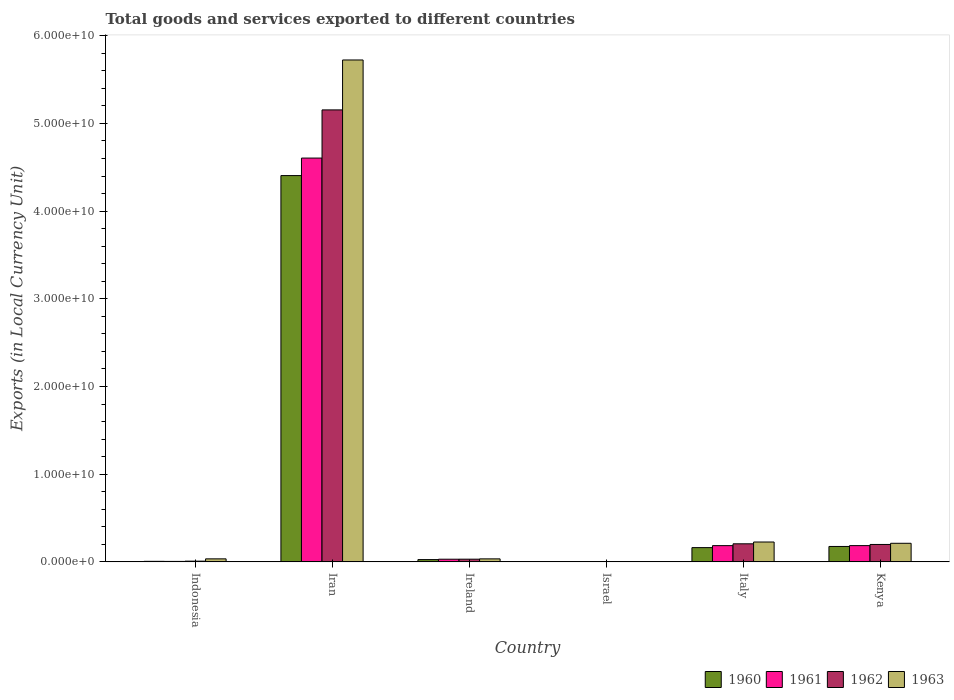Are the number of bars per tick equal to the number of legend labels?
Your answer should be compact. Yes. Are the number of bars on each tick of the X-axis equal?
Ensure brevity in your answer.  Yes. How many bars are there on the 6th tick from the right?
Offer a very short reply. 4. What is the label of the 2nd group of bars from the left?
Your response must be concise. Iran. What is the Amount of goods and services exports in 1960 in Kenya?
Ensure brevity in your answer.  1.76e+09. Across all countries, what is the maximum Amount of goods and services exports in 1961?
Offer a very short reply. 4.60e+1. Across all countries, what is the minimum Amount of goods and services exports in 1960?
Ensure brevity in your answer.  6.19e+04. In which country was the Amount of goods and services exports in 1963 maximum?
Provide a succinct answer. Iran. In which country was the Amount of goods and services exports in 1963 minimum?
Your response must be concise. Israel. What is the total Amount of goods and services exports in 1960 in the graph?
Offer a very short reply. 4.78e+1. What is the difference between the Amount of goods and services exports in 1962 in Israel and that in Kenya?
Provide a succinct answer. -1.99e+09. What is the difference between the Amount of goods and services exports in 1960 in Kenya and the Amount of goods and services exports in 1961 in Indonesia?
Provide a short and direct response. 1.70e+09. What is the average Amount of goods and services exports in 1961 per country?
Provide a short and direct response. 8.35e+09. What is the difference between the Amount of goods and services exports of/in 1962 and Amount of goods and services exports of/in 1961 in Ireland?
Provide a short and direct response. 2.58e+06. What is the ratio of the Amount of goods and services exports in 1963 in Iran to that in Kenya?
Keep it short and to the point. 27. Is the Amount of goods and services exports in 1961 in Indonesia less than that in Iran?
Your answer should be compact. Yes. Is the difference between the Amount of goods and services exports in 1962 in Indonesia and Iran greater than the difference between the Amount of goods and services exports in 1961 in Indonesia and Iran?
Offer a terse response. No. What is the difference between the highest and the second highest Amount of goods and services exports in 1963?
Provide a succinct answer. -5.50e+1. What is the difference between the highest and the lowest Amount of goods and services exports in 1962?
Your response must be concise. 5.15e+1. Is the sum of the Amount of goods and services exports in 1960 in Indonesia and Kenya greater than the maximum Amount of goods and services exports in 1963 across all countries?
Ensure brevity in your answer.  No. Is it the case that in every country, the sum of the Amount of goods and services exports in 1962 and Amount of goods and services exports in 1961 is greater than the sum of Amount of goods and services exports in 1963 and Amount of goods and services exports in 1960?
Make the answer very short. No. What does the 1st bar from the right in Ireland represents?
Make the answer very short. 1963. Are all the bars in the graph horizontal?
Make the answer very short. No. What is the difference between two consecutive major ticks on the Y-axis?
Provide a short and direct response. 1.00e+1. Are the values on the major ticks of Y-axis written in scientific E-notation?
Give a very brief answer. Yes. Does the graph contain grids?
Provide a short and direct response. No. How many legend labels are there?
Make the answer very short. 4. How are the legend labels stacked?
Give a very brief answer. Horizontal. What is the title of the graph?
Keep it short and to the point. Total goods and services exported to different countries. What is the label or title of the X-axis?
Provide a succinct answer. Country. What is the label or title of the Y-axis?
Keep it short and to the point. Exports (in Local Currency Unit). What is the Exports (in Local Currency Unit) in 1960 in Indonesia?
Provide a short and direct response. 6.20e+07. What is the Exports (in Local Currency Unit) of 1961 in Indonesia?
Ensure brevity in your answer.  5.31e+07. What is the Exports (in Local Currency Unit) of 1962 in Indonesia?
Provide a succinct answer. 8.19e+07. What is the Exports (in Local Currency Unit) in 1963 in Indonesia?
Your answer should be very brief. 3.44e+08. What is the Exports (in Local Currency Unit) in 1960 in Iran?
Give a very brief answer. 4.41e+1. What is the Exports (in Local Currency Unit) in 1961 in Iran?
Offer a very short reply. 4.60e+1. What is the Exports (in Local Currency Unit) of 1962 in Iran?
Offer a terse response. 5.15e+1. What is the Exports (in Local Currency Unit) of 1963 in Iran?
Your response must be concise. 5.72e+1. What is the Exports (in Local Currency Unit) in 1960 in Ireland?
Keep it short and to the point. 2.60e+08. What is the Exports (in Local Currency Unit) in 1961 in Ireland?
Give a very brief answer. 3.04e+08. What is the Exports (in Local Currency Unit) in 1962 in Ireland?
Your response must be concise. 3.07e+08. What is the Exports (in Local Currency Unit) in 1963 in Ireland?
Offer a very short reply. 3.43e+08. What is the Exports (in Local Currency Unit) in 1960 in Israel?
Ensure brevity in your answer.  6.19e+04. What is the Exports (in Local Currency Unit) of 1961 in Israel?
Offer a very short reply. 7.24e+04. What is the Exports (in Local Currency Unit) of 1962 in Israel?
Offer a terse response. 1.34e+05. What is the Exports (in Local Currency Unit) of 1963 in Israel?
Your answer should be very brief. 1.67e+05. What is the Exports (in Local Currency Unit) in 1960 in Italy?
Your answer should be very brief. 1.63e+09. What is the Exports (in Local Currency Unit) of 1961 in Italy?
Offer a terse response. 1.85e+09. What is the Exports (in Local Currency Unit) in 1962 in Italy?
Give a very brief answer. 2.06e+09. What is the Exports (in Local Currency Unit) in 1963 in Italy?
Your response must be concise. 2.27e+09. What is the Exports (in Local Currency Unit) in 1960 in Kenya?
Offer a very short reply. 1.76e+09. What is the Exports (in Local Currency Unit) of 1961 in Kenya?
Ensure brevity in your answer.  1.85e+09. What is the Exports (in Local Currency Unit) of 1962 in Kenya?
Offer a terse response. 1.99e+09. What is the Exports (in Local Currency Unit) in 1963 in Kenya?
Provide a succinct answer. 2.12e+09. Across all countries, what is the maximum Exports (in Local Currency Unit) of 1960?
Offer a terse response. 4.41e+1. Across all countries, what is the maximum Exports (in Local Currency Unit) of 1961?
Ensure brevity in your answer.  4.60e+1. Across all countries, what is the maximum Exports (in Local Currency Unit) of 1962?
Your response must be concise. 5.15e+1. Across all countries, what is the maximum Exports (in Local Currency Unit) in 1963?
Keep it short and to the point. 5.72e+1. Across all countries, what is the minimum Exports (in Local Currency Unit) in 1960?
Make the answer very short. 6.19e+04. Across all countries, what is the minimum Exports (in Local Currency Unit) of 1961?
Provide a succinct answer. 7.24e+04. Across all countries, what is the minimum Exports (in Local Currency Unit) of 1962?
Offer a very short reply. 1.34e+05. Across all countries, what is the minimum Exports (in Local Currency Unit) of 1963?
Provide a succinct answer. 1.67e+05. What is the total Exports (in Local Currency Unit) in 1960 in the graph?
Offer a terse response. 4.78e+1. What is the total Exports (in Local Currency Unit) of 1961 in the graph?
Give a very brief answer. 5.01e+1. What is the total Exports (in Local Currency Unit) of 1962 in the graph?
Keep it short and to the point. 5.60e+1. What is the total Exports (in Local Currency Unit) in 1963 in the graph?
Give a very brief answer. 6.23e+1. What is the difference between the Exports (in Local Currency Unit) in 1960 in Indonesia and that in Iran?
Offer a very short reply. -4.40e+1. What is the difference between the Exports (in Local Currency Unit) in 1961 in Indonesia and that in Iran?
Keep it short and to the point. -4.60e+1. What is the difference between the Exports (in Local Currency Unit) in 1962 in Indonesia and that in Iran?
Make the answer very short. -5.15e+1. What is the difference between the Exports (in Local Currency Unit) of 1963 in Indonesia and that in Iran?
Make the answer very short. -5.69e+1. What is the difference between the Exports (in Local Currency Unit) in 1960 in Indonesia and that in Ireland?
Ensure brevity in your answer.  -1.98e+08. What is the difference between the Exports (in Local Currency Unit) of 1961 in Indonesia and that in Ireland?
Offer a terse response. -2.51e+08. What is the difference between the Exports (in Local Currency Unit) of 1962 in Indonesia and that in Ireland?
Provide a short and direct response. -2.25e+08. What is the difference between the Exports (in Local Currency Unit) of 1963 in Indonesia and that in Ireland?
Your answer should be compact. 1.22e+06. What is the difference between the Exports (in Local Currency Unit) of 1960 in Indonesia and that in Israel?
Your answer should be compact. 6.19e+07. What is the difference between the Exports (in Local Currency Unit) of 1961 in Indonesia and that in Israel?
Offer a terse response. 5.31e+07. What is the difference between the Exports (in Local Currency Unit) in 1962 in Indonesia and that in Israel?
Offer a very short reply. 8.18e+07. What is the difference between the Exports (in Local Currency Unit) of 1963 in Indonesia and that in Israel?
Your answer should be compact. 3.44e+08. What is the difference between the Exports (in Local Currency Unit) of 1960 in Indonesia and that in Italy?
Make the answer very short. -1.56e+09. What is the difference between the Exports (in Local Currency Unit) of 1961 in Indonesia and that in Italy?
Your answer should be compact. -1.80e+09. What is the difference between the Exports (in Local Currency Unit) in 1962 in Indonesia and that in Italy?
Your response must be concise. -1.98e+09. What is the difference between the Exports (in Local Currency Unit) of 1963 in Indonesia and that in Italy?
Make the answer very short. -1.92e+09. What is the difference between the Exports (in Local Currency Unit) in 1960 in Indonesia and that in Kenya?
Your response must be concise. -1.70e+09. What is the difference between the Exports (in Local Currency Unit) of 1961 in Indonesia and that in Kenya?
Give a very brief answer. -1.80e+09. What is the difference between the Exports (in Local Currency Unit) of 1962 in Indonesia and that in Kenya?
Your answer should be very brief. -1.90e+09. What is the difference between the Exports (in Local Currency Unit) in 1963 in Indonesia and that in Kenya?
Provide a short and direct response. -1.78e+09. What is the difference between the Exports (in Local Currency Unit) of 1960 in Iran and that in Ireland?
Your answer should be compact. 4.38e+1. What is the difference between the Exports (in Local Currency Unit) in 1961 in Iran and that in Ireland?
Give a very brief answer. 4.57e+1. What is the difference between the Exports (in Local Currency Unit) in 1962 in Iran and that in Ireland?
Provide a succinct answer. 5.12e+1. What is the difference between the Exports (in Local Currency Unit) of 1963 in Iran and that in Ireland?
Ensure brevity in your answer.  5.69e+1. What is the difference between the Exports (in Local Currency Unit) of 1960 in Iran and that in Israel?
Ensure brevity in your answer.  4.41e+1. What is the difference between the Exports (in Local Currency Unit) of 1961 in Iran and that in Israel?
Ensure brevity in your answer.  4.60e+1. What is the difference between the Exports (in Local Currency Unit) in 1962 in Iran and that in Israel?
Provide a short and direct response. 5.15e+1. What is the difference between the Exports (in Local Currency Unit) of 1963 in Iran and that in Israel?
Your answer should be very brief. 5.72e+1. What is the difference between the Exports (in Local Currency Unit) in 1960 in Iran and that in Italy?
Make the answer very short. 4.24e+1. What is the difference between the Exports (in Local Currency Unit) of 1961 in Iran and that in Italy?
Provide a succinct answer. 4.42e+1. What is the difference between the Exports (in Local Currency Unit) in 1962 in Iran and that in Italy?
Offer a terse response. 4.95e+1. What is the difference between the Exports (in Local Currency Unit) in 1963 in Iran and that in Italy?
Your answer should be very brief. 5.50e+1. What is the difference between the Exports (in Local Currency Unit) in 1960 in Iran and that in Kenya?
Give a very brief answer. 4.23e+1. What is the difference between the Exports (in Local Currency Unit) of 1961 in Iran and that in Kenya?
Offer a very short reply. 4.42e+1. What is the difference between the Exports (in Local Currency Unit) of 1962 in Iran and that in Kenya?
Provide a succinct answer. 4.96e+1. What is the difference between the Exports (in Local Currency Unit) of 1963 in Iran and that in Kenya?
Keep it short and to the point. 5.51e+1. What is the difference between the Exports (in Local Currency Unit) of 1960 in Ireland and that in Israel?
Provide a short and direct response. 2.60e+08. What is the difference between the Exports (in Local Currency Unit) of 1961 in Ireland and that in Israel?
Keep it short and to the point. 3.04e+08. What is the difference between the Exports (in Local Currency Unit) of 1962 in Ireland and that in Israel?
Ensure brevity in your answer.  3.06e+08. What is the difference between the Exports (in Local Currency Unit) in 1963 in Ireland and that in Israel?
Offer a very short reply. 3.43e+08. What is the difference between the Exports (in Local Currency Unit) of 1960 in Ireland and that in Italy?
Your response must be concise. -1.37e+09. What is the difference between the Exports (in Local Currency Unit) of 1961 in Ireland and that in Italy?
Give a very brief answer. -1.55e+09. What is the difference between the Exports (in Local Currency Unit) in 1962 in Ireland and that in Italy?
Offer a very short reply. -1.75e+09. What is the difference between the Exports (in Local Currency Unit) in 1963 in Ireland and that in Italy?
Make the answer very short. -1.92e+09. What is the difference between the Exports (in Local Currency Unit) of 1960 in Ireland and that in Kenya?
Provide a succinct answer. -1.50e+09. What is the difference between the Exports (in Local Currency Unit) in 1961 in Ireland and that in Kenya?
Provide a succinct answer. -1.55e+09. What is the difference between the Exports (in Local Currency Unit) in 1962 in Ireland and that in Kenya?
Offer a very short reply. -1.68e+09. What is the difference between the Exports (in Local Currency Unit) of 1963 in Ireland and that in Kenya?
Offer a very short reply. -1.78e+09. What is the difference between the Exports (in Local Currency Unit) in 1960 in Israel and that in Italy?
Your answer should be compact. -1.63e+09. What is the difference between the Exports (in Local Currency Unit) in 1961 in Israel and that in Italy?
Offer a very short reply. -1.85e+09. What is the difference between the Exports (in Local Currency Unit) of 1962 in Israel and that in Italy?
Provide a short and direct response. -2.06e+09. What is the difference between the Exports (in Local Currency Unit) of 1963 in Israel and that in Italy?
Ensure brevity in your answer.  -2.27e+09. What is the difference between the Exports (in Local Currency Unit) in 1960 in Israel and that in Kenya?
Your response must be concise. -1.76e+09. What is the difference between the Exports (in Local Currency Unit) in 1961 in Israel and that in Kenya?
Provide a succinct answer. -1.85e+09. What is the difference between the Exports (in Local Currency Unit) in 1962 in Israel and that in Kenya?
Your answer should be compact. -1.99e+09. What is the difference between the Exports (in Local Currency Unit) of 1963 in Israel and that in Kenya?
Offer a very short reply. -2.12e+09. What is the difference between the Exports (in Local Currency Unit) in 1960 in Italy and that in Kenya?
Make the answer very short. -1.31e+08. What is the difference between the Exports (in Local Currency Unit) of 1961 in Italy and that in Kenya?
Offer a very short reply. -1.45e+06. What is the difference between the Exports (in Local Currency Unit) of 1962 in Italy and that in Kenya?
Ensure brevity in your answer.  7.40e+07. What is the difference between the Exports (in Local Currency Unit) of 1963 in Italy and that in Kenya?
Your answer should be compact. 1.46e+08. What is the difference between the Exports (in Local Currency Unit) of 1960 in Indonesia and the Exports (in Local Currency Unit) of 1961 in Iran?
Your answer should be very brief. -4.60e+1. What is the difference between the Exports (in Local Currency Unit) in 1960 in Indonesia and the Exports (in Local Currency Unit) in 1962 in Iran?
Give a very brief answer. -5.15e+1. What is the difference between the Exports (in Local Currency Unit) in 1960 in Indonesia and the Exports (in Local Currency Unit) in 1963 in Iran?
Your response must be concise. -5.72e+1. What is the difference between the Exports (in Local Currency Unit) of 1961 in Indonesia and the Exports (in Local Currency Unit) of 1962 in Iran?
Give a very brief answer. -5.15e+1. What is the difference between the Exports (in Local Currency Unit) of 1961 in Indonesia and the Exports (in Local Currency Unit) of 1963 in Iran?
Your response must be concise. -5.72e+1. What is the difference between the Exports (in Local Currency Unit) in 1962 in Indonesia and the Exports (in Local Currency Unit) in 1963 in Iran?
Give a very brief answer. -5.72e+1. What is the difference between the Exports (in Local Currency Unit) of 1960 in Indonesia and the Exports (in Local Currency Unit) of 1961 in Ireland?
Offer a very short reply. -2.42e+08. What is the difference between the Exports (in Local Currency Unit) in 1960 in Indonesia and the Exports (in Local Currency Unit) in 1962 in Ireland?
Your response must be concise. -2.45e+08. What is the difference between the Exports (in Local Currency Unit) in 1960 in Indonesia and the Exports (in Local Currency Unit) in 1963 in Ireland?
Give a very brief answer. -2.81e+08. What is the difference between the Exports (in Local Currency Unit) in 1961 in Indonesia and the Exports (in Local Currency Unit) in 1962 in Ireland?
Make the answer very short. -2.53e+08. What is the difference between the Exports (in Local Currency Unit) in 1961 in Indonesia and the Exports (in Local Currency Unit) in 1963 in Ireland?
Offer a very short reply. -2.90e+08. What is the difference between the Exports (in Local Currency Unit) of 1962 in Indonesia and the Exports (in Local Currency Unit) of 1963 in Ireland?
Provide a succinct answer. -2.61e+08. What is the difference between the Exports (in Local Currency Unit) of 1960 in Indonesia and the Exports (in Local Currency Unit) of 1961 in Israel?
Provide a short and direct response. 6.19e+07. What is the difference between the Exports (in Local Currency Unit) in 1960 in Indonesia and the Exports (in Local Currency Unit) in 1962 in Israel?
Your answer should be very brief. 6.18e+07. What is the difference between the Exports (in Local Currency Unit) of 1960 in Indonesia and the Exports (in Local Currency Unit) of 1963 in Israel?
Make the answer very short. 6.18e+07. What is the difference between the Exports (in Local Currency Unit) of 1961 in Indonesia and the Exports (in Local Currency Unit) of 1962 in Israel?
Your response must be concise. 5.30e+07. What is the difference between the Exports (in Local Currency Unit) of 1961 in Indonesia and the Exports (in Local Currency Unit) of 1963 in Israel?
Ensure brevity in your answer.  5.30e+07. What is the difference between the Exports (in Local Currency Unit) in 1962 in Indonesia and the Exports (in Local Currency Unit) in 1963 in Israel?
Your answer should be compact. 8.17e+07. What is the difference between the Exports (in Local Currency Unit) in 1960 in Indonesia and the Exports (in Local Currency Unit) in 1961 in Italy?
Your answer should be very brief. -1.79e+09. What is the difference between the Exports (in Local Currency Unit) in 1960 in Indonesia and the Exports (in Local Currency Unit) in 1962 in Italy?
Provide a short and direct response. -2.00e+09. What is the difference between the Exports (in Local Currency Unit) in 1960 in Indonesia and the Exports (in Local Currency Unit) in 1963 in Italy?
Your answer should be compact. -2.20e+09. What is the difference between the Exports (in Local Currency Unit) of 1961 in Indonesia and the Exports (in Local Currency Unit) of 1962 in Italy?
Make the answer very short. -2.01e+09. What is the difference between the Exports (in Local Currency Unit) of 1961 in Indonesia and the Exports (in Local Currency Unit) of 1963 in Italy?
Your answer should be compact. -2.21e+09. What is the difference between the Exports (in Local Currency Unit) in 1962 in Indonesia and the Exports (in Local Currency Unit) in 1963 in Italy?
Provide a succinct answer. -2.18e+09. What is the difference between the Exports (in Local Currency Unit) of 1960 in Indonesia and the Exports (in Local Currency Unit) of 1961 in Kenya?
Your answer should be very brief. -1.79e+09. What is the difference between the Exports (in Local Currency Unit) of 1960 in Indonesia and the Exports (in Local Currency Unit) of 1962 in Kenya?
Provide a short and direct response. -1.92e+09. What is the difference between the Exports (in Local Currency Unit) of 1960 in Indonesia and the Exports (in Local Currency Unit) of 1963 in Kenya?
Give a very brief answer. -2.06e+09. What is the difference between the Exports (in Local Currency Unit) of 1961 in Indonesia and the Exports (in Local Currency Unit) of 1962 in Kenya?
Provide a succinct answer. -1.93e+09. What is the difference between the Exports (in Local Currency Unit) in 1961 in Indonesia and the Exports (in Local Currency Unit) in 1963 in Kenya?
Offer a terse response. -2.07e+09. What is the difference between the Exports (in Local Currency Unit) in 1962 in Indonesia and the Exports (in Local Currency Unit) in 1963 in Kenya?
Keep it short and to the point. -2.04e+09. What is the difference between the Exports (in Local Currency Unit) of 1960 in Iran and the Exports (in Local Currency Unit) of 1961 in Ireland?
Ensure brevity in your answer.  4.37e+1. What is the difference between the Exports (in Local Currency Unit) in 1960 in Iran and the Exports (in Local Currency Unit) in 1962 in Ireland?
Give a very brief answer. 4.37e+1. What is the difference between the Exports (in Local Currency Unit) in 1960 in Iran and the Exports (in Local Currency Unit) in 1963 in Ireland?
Your response must be concise. 4.37e+1. What is the difference between the Exports (in Local Currency Unit) in 1961 in Iran and the Exports (in Local Currency Unit) in 1962 in Ireland?
Offer a very short reply. 4.57e+1. What is the difference between the Exports (in Local Currency Unit) in 1961 in Iran and the Exports (in Local Currency Unit) in 1963 in Ireland?
Provide a succinct answer. 4.57e+1. What is the difference between the Exports (in Local Currency Unit) in 1962 in Iran and the Exports (in Local Currency Unit) in 1963 in Ireland?
Give a very brief answer. 5.12e+1. What is the difference between the Exports (in Local Currency Unit) of 1960 in Iran and the Exports (in Local Currency Unit) of 1961 in Israel?
Keep it short and to the point. 4.41e+1. What is the difference between the Exports (in Local Currency Unit) of 1960 in Iran and the Exports (in Local Currency Unit) of 1962 in Israel?
Provide a short and direct response. 4.41e+1. What is the difference between the Exports (in Local Currency Unit) in 1960 in Iran and the Exports (in Local Currency Unit) in 1963 in Israel?
Offer a terse response. 4.41e+1. What is the difference between the Exports (in Local Currency Unit) in 1961 in Iran and the Exports (in Local Currency Unit) in 1962 in Israel?
Your response must be concise. 4.60e+1. What is the difference between the Exports (in Local Currency Unit) in 1961 in Iran and the Exports (in Local Currency Unit) in 1963 in Israel?
Offer a terse response. 4.60e+1. What is the difference between the Exports (in Local Currency Unit) of 1962 in Iran and the Exports (in Local Currency Unit) of 1963 in Israel?
Offer a very short reply. 5.15e+1. What is the difference between the Exports (in Local Currency Unit) in 1960 in Iran and the Exports (in Local Currency Unit) in 1961 in Italy?
Offer a terse response. 4.22e+1. What is the difference between the Exports (in Local Currency Unit) of 1960 in Iran and the Exports (in Local Currency Unit) of 1962 in Italy?
Your answer should be compact. 4.20e+1. What is the difference between the Exports (in Local Currency Unit) in 1960 in Iran and the Exports (in Local Currency Unit) in 1963 in Italy?
Offer a terse response. 4.18e+1. What is the difference between the Exports (in Local Currency Unit) in 1961 in Iran and the Exports (in Local Currency Unit) in 1962 in Italy?
Keep it short and to the point. 4.40e+1. What is the difference between the Exports (in Local Currency Unit) of 1961 in Iran and the Exports (in Local Currency Unit) of 1963 in Italy?
Keep it short and to the point. 4.38e+1. What is the difference between the Exports (in Local Currency Unit) in 1962 in Iran and the Exports (in Local Currency Unit) in 1963 in Italy?
Provide a succinct answer. 4.93e+1. What is the difference between the Exports (in Local Currency Unit) of 1960 in Iran and the Exports (in Local Currency Unit) of 1961 in Kenya?
Provide a succinct answer. 4.22e+1. What is the difference between the Exports (in Local Currency Unit) of 1960 in Iran and the Exports (in Local Currency Unit) of 1962 in Kenya?
Offer a terse response. 4.21e+1. What is the difference between the Exports (in Local Currency Unit) in 1960 in Iran and the Exports (in Local Currency Unit) in 1963 in Kenya?
Make the answer very short. 4.19e+1. What is the difference between the Exports (in Local Currency Unit) in 1961 in Iran and the Exports (in Local Currency Unit) in 1962 in Kenya?
Ensure brevity in your answer.  4.41e+1. What is the difference between the Exports (in Local Currency Unit) of 1961 in Iran and the Exports (in Local Currency Unit) of 1963 in Kenya?
Offer a terse response. 4.39e+1. What is the difference between the Exports (in Local Currency Unit) of 1962 in Iran and the Exports (in Local Currency Unit) of 1963 in Kenya?
Offer a terse response. 4.94e+1. What is the difference between the Exports (in Local Currency Unit) of 1960 in Ireland and the Exports (in Local Currency Unit) of 1961 in Israel?
Offer a very short reply. 2.60e+08. What is the difference between the Exports (in Local Currency Unit) of 1960 in Ireland and the Exports (in Local Currency Unit) of 1962 in Israel?
Offer a terse response. 2.60e+08. What is the difference between the Exports (in Local Currency Unit) of 1960 in Ireland and the Exports (in Local Currency Unit) of 1963 in Israel?
Your answer should be compact. 2.60e+08. What is the difference between the Exports (in Local Currency Unit) in 1961 in Ireland and the Exports (in Local Currency Unit) in 1962 in Israel?
Make the answer very short. 3.04e+08. What is the difference between the Exports (in Local Currency Unit) in 1961 in Ireland and the Exports (in Local Currency Unit) in 1963 in Israel?
Your answer should be compact. 3.04e+08. What is the difference between the Exports (in Local Currency Unit) of 1962 in Ireland and the Exports (in Local Currency Unit) of 1963 in Israel?
Keep it short and to the point. 3.06e+08. What is the difference between the Exports (in Local Currency Unit) in 1960 in Ireland and the Exports (in Local Currency Unit) in 1961 in Italy?
Provide a succinct answer. -1.59e+09. What is the difference between the Exports (in Local Currency Unit) of 1960 in Ireland and the Exports (in Local Currency Unit) of 1962 in Italy?
Your response must be concise. -1.80e+09. What is the difference between the Exports (in Local Currency Unit) in 1960 in Ireland and the Exports (in Local Currency Unit) in 1963 in Italy?
Your response must be concise. -2.01e+09. What is the difference between the Exports (in Local Currency Unit) in 1961 in Ireland and the Exports (in Local Currency Unit) in 1962 in Italy?
Offer a terse response. -1.76e+09. What is the difference between the Exports (in Local Currency Unit) of 1961 in Ireland and the Exports (in Local Currency Unit) of 1963 in Italy?
Provide a succinct answer. -1.96e+09. What is the difference between the Exports (in Local Currency Unit) in 1962 in Ireland and the Exports (in Local Currency Unit) in 1963 in Italy?
Give a very brief answer. -1.96e+09. What is the difference between the Exports (in Local Currency Unit) in 1960 in Ireland and the Exports (in Local Currency Unit) in 1961 in Kenya?
Your response must be concise. -1.59e+09. What is the difference between the Exports (in Local Currency Unit) of 1960 in Ireland and the Exports (in Local Currency Unit) of 1962 in Kenya?
Your answer should be very brief. -1.73e+09. What is the difference between the Exports (in Local Currency Unit) of 1960 in Ireland and the Exports (in Local Currency Unit) of 1963 in Kenya?
Your response must be concise. -1.86e+09. What is the difference between the Exports (in Local Currency Unit) of 1961 in Ireland and the Exports (in Local Currency Unit) of 1962 in Kenya?
Provide a succinct answer. -1.68e+09. What is the difference between the Exports (in Local Currency Unit) in 1961 in Ireland and the Exports (in Local Currency Unit) in 1963 in Kenya?
Your answer should be very brief. -1.82e+09. What is the difference between the Exports (in Local Currency Unit) of 1962 in Ireland and the Exports (in Local Currency Unit) of 1963 in Kenya?
Provide a short and direct response. -1.81e+09. What is the difference between the Exports (in Local Currency Unit) of 1960 in Israel and the Exports (in Local Currency Unit) of 1961 in Italy?
Offer a very short reply. -1.85e+09. What is the difference between the Exports (in Local Currency Unit) in 1960 in Israel and the Exports (in Local Currency Unit) in 1962 in Italy?
Offer a terse response. -2.06e+09. What is the difference between the Exports (in Local Currency Unit) of 1960 in Israel and the Exports (in Local Currency Unit) of 1963 in Italy?
Offer a very short reply. -2.27e+09. What is the difference between the Exports (in Local Currency Unit) in 1961 in Israel and the Exports (in Local Currency Unit) in 1962 in Italy?
Your answer should be very brief. -2.06e+09. What is the difference between the Exports (in Local Currency Unit) in 1961 in Israel and the Exports (in Local Currency Unit) in 1963 in Italy?
Provide a short and direct response. -2.27e+09. What is the difference between the Exports (in Local Currency Unit) in 1962 in Israel and the Exports (in Local Currency Unit) in 1963 in Italy?
Give a very brief answer. -2.27e+09. What is the difference between the Exports (in Local Currency Unit) of 1960 in Israel and the Exports (in Local Currency Unit) of 1961 in Kenya?
Keep it short and to the point. -1.85e+09. What is the difference between the Exports (in Local Currency Unit) in 1960 in Israel and the Exports (in Local Currency Unit) in 1962 in Kenya?
Make the answer very short. -1.99e+09. What is the difference between the Exports (in Local Currency Unit) in 1960 in Israel and the Exports (in Local Currency Unit) in 1963 in Kenya?
Your answer should be very brief. -2.12e+09. What is the difference between the Exports (in Local Currency Unit) of 1961 in Israel and the Exports (in Local Currency Unit) of 1962 in Kenya?
Give a very brief answer. -1.99e+09. What is the difference between the Exports (in Local Currency Unit) of 1961 in Israel and the Exports (in Local Currency Unit) of 1963 in Kenya?
Offer a terse response. -2.12e+09. What is the difference between the Exports (in Local Currency Unit) of 1962 in Israel and the Exports (in Local Currency Unit) of 1963 in Kenya?
Provide a short and direct response. -2.12e+09. What is the difference between the Exports (in Local Currency Unit) in 1960 in Italy and the Exports (in Local Currency Unit) in 1961 in Kenya?
Give a very brief answer. -2.27e+08. What is the difference between the Exports (in Local Currency Unit) in 1960 in Italy and the Exports (in Local Currency Unit) in 1962 in Kenya?
Your answer should be very brief. -3.60e+08. What is the difference between the Exports (in Local Currency Unit) of 1960 in Italy and the Exports (in Local Currency Unit) of 1963 in Kenya?
Ensure brevity in your answer.  -4.94e+08. What is the difference between the Exports (in Local Currency Unit) of 1961 in Italy and the Exports (in Local Currency Unit) of 1962 in Kenya?
Keep it short and to the point. -1.35e+08. What is the difference between the Exports (in Local Currency Unit) in 1961 in Italy and the Exports (in Local Currency Unit) in 1963 in Kenya?
Provide a succinct answer. -2.68e+08. What is the difference between the Exports (in Local Currency Unit) of 1962 in Italy and the Exports (in Local Currency Unit) of 1963 in Kenya?
Your response must be concise. -5.95e+07. What is the average Exports (in Local Currency Unit) of 1960 per country?
Give a very brief answer. 7.96e+09. What is the average Exports (in Local Currency Unit) of 1961 per country?
Provide a short and direct response. 8.35e+09. What is the average Exports (in Local Currency Unit) in 1962 per country?
Your answer should be compact. 9.33e+09. What is the average Exports (in Local Currency Unit) in 1963 per country?
Make the answer very short. 1.04e+1. What is the difference between the Exports (in Local Currency Unit) of 1960 and Exports (in Local Currency Unit) of 1961 in Indonesia?
Make the answer very short. 8.85e+06. What is the difference between the Exports (in Local Currency Unit) of 1960 and Exports (in Local Currency Unit) of 1962 in Indonesia?
Ensure brevity in your answer.  -1.99e+07. What is the difference between the Exports (in Local Currency Unit) in 1960 and Exports (in Local Currency Unit) in 1963 in Indonesia?
Make the answer very short. -2.82e+08. What is the difference between the Exports (in Local Currency Unit) of 1961 and Exports (in Local Currency Unit) of 1962 in Indonesia?
Keep it short and to the point. -2.88e+07. What is the difference between the Exports (in Local Currency Unit) of 1961 and Exports (in Local Currency Unit) of 1963 in Indonesia?
Provide a succinct answer. -2.91e+08. What is the difference between the Exports (in Local Currency Unit) of 1962 and Exports (in Local Currency Unit) of 1963 in Indonesia?
Your answer should be compact. -2.62e+08. What is the difference between the Exports (in Local Currency Unit) of 1960 and Exports (in Local Currency Unit) of 1961 in Iran?
Offer a very short reply. -2.00e+09. What is the difference between the Exports (in Local Currency Unit) in 1960 and Exports (in Local Currency Unit) in 1962 in Iran?
Keep it short and to the point. -7.49e+09. What is the difference between the Exports (in Local Currency Unit) of 1960 and Exports (in Local Currency Unit) of 1963 in Iran?
Offer a terse response. -1.32e+1. What is the difference between the Exports (in Local Currency Unit) of 1961 and Exports (in Local Currency Unit) of 1962 in Iran?
Your answer should be very brief. -5.49e+09. What is the difference between the Exports (in Local Currency Unit) of 1961 and Exports (in Local Currency Unit) of 1963 in Iran?
Provide a succinct answer. -1.12e+1. What is the difference between the Exports (in Local Currency Unit) of 1962 and Exports (in Local Currency Unit) of 1963 in Iran?
Ensure brevity in your answer.  -5.69e+09. What is the difference between the Exports (in Local Currency Unit) of 1960 and Exports (in Local Currency Unit) of 1961 in Ireland?
Offer a terse response. -4.43e+07. What is the difference between the Exports (in Local Currency Unit) of 1960 and Exports (in Local Currency Unit) of 1962 in Ireland?
Your answer should be compact. -4.69e+07. What is the difference between the Exports (in Local Currency Unit) in 1960 and Exports (in Local Currency Unit) in 1963 in Ireland?
Ensure brevity in your answer.  -8.33e+07. What is the difference between the Exports (in Local Currency Unit) of 1961 and Exports (in Local Currency Unit) of 1962 in Ireland?
Make the answer very short. -2.58e+06. What is the difference between the Exports (in Local Currency Unit) in 1961 and Exports (in Local Currency Unit) in 1963 in Ireland?
Ensure brevity in your answer.  -3.90e+07. What is the difference between the Exports (in Local Currency Unit) in 1962 and Exports (in Local Currency Unit) in 1963 in Ireland?
Give a very brief answer. -3.64e+07. What is the difference between the Exports (in Local Currency Unit) in 1960 and Exports (in Local Currency Unit) in 1961 in Israel?
Give a very brief answer. -1.05e+04. What is the difference between the Exports (in Local Currency Unit) in 1960 and Exports (in Local Currency Unit) in 1962 in Israel?
Offer a terse response. -7.21e+04. What is the difference between the Exports (in Local Currency Unit) of 1960 and Exports (in Local Currency Unit) of 1963 in Israel?
Ensure brevity in your answer.  -1.06e+05. What is the difference between the Exports (in Local Currency Unit) in 1961 and Exports (in Local Currency Unit) in 1962 in Israel?
Provide a succinct answer. -6.16e+04. What is the difference between the Exports (in Local Currency Unit) of 1961 and Exports (in Local Currency Unit) of 1963 in Israel?
Give a very brief answer. -9.50e+04. What is the difference between the Exports (in Local Currency Unit) in 1962 and Exports (in Local Currency Unit) in 1963 in Israel?
Your response must be concise. -3.34e+04. What is the difference between the Exports (in Local Currency Unit) in 1960 and Exports (in Local Currency Unit) in 1961 in Italy?
Ensure brevity in your answer.  -2.25e+08. What is the difference between the Exports (in Local Currency Unit) of 1960 and Exports (in Local Currency Unit) of 1962 in Italy?
Keep it short and to the point. -4.34e+08. What is the difference between the Exports (in Local Currency Unit) of 1960 and Exports (in Local Currency Unit) of 1963 in Italy?
Ensure brevity in your answer.  -6.40e+08. What is the difference between the Exports (in Local Currency Unit) of 1961 and Exports (in Local Currency Unit) of 1962 in Italy?
Your response must be concise. -2.09e+08. What is the difference between the Exports (in Local Currency Unit) in 1961 and Exports (in Local Currency Unit) in 1963 in Italy?
Make the answer very short. -4.14e+08. What is the difference between the Exports (in Local Currency Unit) in 1962 and Exports (in Local Currency Unit) in 1963 in Italy?
Ensure brevity in your answer.  -2.05e+08. What is the difference between the Exports (in Local Currency Unit) of 1960 and Exports (in Local Currency Unit) of 1961 in Kenya?
Your answer should be compact. -9.56e+07. What is the difference between the Exports (in Local Currency Unit) of 1960 and Exports (in Local Currency Unit) of 1962 in Kenya?
Give a very brief answer. -2.29e+08. What is the difference between the Exports (in Local Currency Unit) of 1960 and Exports (in Local Currency Unit) of 1963 in Kenya?
Your response must be concise. -3.63e+08. What is the difference between the Exports (in Local Currency Unit) in 1961 and Exports (in Local Currency Unit) in 1962 in Kenya?
Provide a short and direct response. -1.33e+08. What is the difference between the Exports (in Local Currency Unit) of 1961 and Exports (in Local Currency Unit) of 1963 in Kenya?
Provide a succinct answer. -2.67e+08. What is the difference between the Exports (in Local Currency Unit) in 1962 and Exports (in Local Currency Unit) in 1963 in Kenya?
Provide a succinct answer. -1.34e+08. What is the ratio of the Exports (in Local Currency Unit) of 1960 in Indonesia to that in Iran?
Make the answer very short. 0. What is the ratio of the Exports (in Local Currency Unit) in 1961 in Indonesia to that in Iran?
Provide a succinct answer. 0. What is the ratio of the Exports (in Local Currency Unit) of 1962 in Indonesia to that in Iran?
Provide a succinct answer. 0. What is the ratio of the Exports (in Local Currency Unit) of 1963 in Indonesia to that in Iran?
Provide a succinct answer. 0.01. What is the ratio of the Exports (in Local Currency Unit) of 1960 in Indonesia to that in Ireland?
Make the answer very short. 0.24. What is the ratio of the Exports (in Local Currency Unit) in 1961 in Indonesia to that in Ireland?
Provide a short and direct response. 0.17. What is the ratio of the Exports (in Local Currency Unit) of 1962 in Indonesia to that in Ireland?
Offer a terse response. 0.27. What is the ratio of the Exports (in Local Currency Unit) of 1960 in Indonesia to that in Israel?
Your answer should be very brief. 1001.31. What is the ratio of the Exports (in Local Currency Unit) of 1961 in Indonesia to that in Israel?
Ensure brevity in your answer.  733.8. What is the ratio of the Exports (in Local Currency Unit) of 1962 in Indonesia to that in Israel?
Give a very brief answer. 611.22. What is the ratio of the Exports (in Local Currency Unit) of 1963 in Indonesia to that in Israel?
Your response must be concise. 2056.26. What is the ratio of the Exports (in Local Currency Unit) in 1960 in Indonesia to that in Italy?
Your response must be concise. 0.04. What is the ratio of the Exports (in Local Currency Unit) in 1961 in Indonesia to that in Italy?
Your answer should be very brief. 0.03. What is the ratio of the Exports (in Local Currency Unit) in 1962 in Indonesia to that in Italy?
Give a very brief answer. 0.04. What is the ratio of the Exports (in Local Currency Unit) of 1963 in Indonesia to that in Italy?
Ensure brevity in your answer.  0.15. What is the ratio of the Exports (in Local Currency Unit) of 1960 in Indonesia to that in Kenya?
Make the answer very short. 0.04. What is the ratio of the Exports (in Local Currency Unit) of 1961 in Indonesia to that in Kenya?
Offer a terse response. 0.03. What is the ratio of the Exports (in Local Currency Unit) in 1962 in Indonesia to that in Kenya?
Provide a short and direct response. 0.04. What is the ratio of the Exports (in Local Currency Unit) of 1963 in Indonesia to that in Kenya?
Provide a short and direct response. 0.16. What is the ratio of the Exports (in Local Currency Unit) of 1960 in Iran to that in Ireland?
Provide a succinct answer. 169.64. What is the ratio of the Exports (in Local Currency Unit) of 1961 in Iran to that in Ireland?
Your response must be concise. 151.49. What is the ratio of the Exports (in Local Currency Unit) of 1962 in Iran to that in Ireland?
Offer a terse response. 168.13. What is the ratio of the Exports (in Local Currency Unit) of 1963 in Iran to that in Ireland?
Offer a very short reply. 166.87. What is the ratio of the Exports (in Local Currency Unit) of 1960 in Iran to that in Israel?
Provide a succinct answer. 7.12e+05. What is the ratio of the Exports (in Local Currency Unit) of 1961 in Iran to that in Israel?
Your answer should be very brief. 6.36e+05. What is the ratio of the Exports (in Local Currency Unit) in 1962 in Iran to that in Israel?
Ensure brevity in your answer.  3.85e+05. What is the ratio of the Exports (in Local Currency Unit) in 1963 in Iran to that in Israel?
Provide a succinct answer. 3.42e+05. What is the ratio of the Exports (in Local Currency Unit) in 1960 in Iran to that in Italy?
Your response must be concise. 27.08. What is the ratio of the Exports (in Local Currency Unit) of 1961 in Iran to that in Italy?
Make the answer very short. 24.87. What is the ratio of the Exports (in Local Currency Unit) in 1962 in Iran to that in Italy?
Keep it short and to the point. 25.01. What is the ratio of the Exports (in Local Currency Unit) of 1963 in Iran to that in Italy?
Your response must be concise. 25.26. What is the ratio of the Exports (in Local Currency Unit) in 1960 in Iran to that in Kenya?
Provide a short and direct response. 25.07. What is the ratio of the Exports (in Local Currency Unit) in 1961 in Iran to that in Kenya?
Ensure brevity in your answer.  24.85. What is the ratio of the Exports (in Local Currency Unit) in 1962 in Iran to that in Kenya?
Give a very brief answer. 25.95. What is the ratio of the Exports (in Local Currency Unit) of 1963 in Iran to that in Kenya?
Ensure brevity in your answer.  27. What is the ratio of the Exports (in Local Currency Unit) in 1960 in Ireland to that in Israel?
Your answer should be compact. 4195.01. What is the ratio of the Exports (in Local Currency Unit) of 1961 in Ireland to that in Israel?
Your response must be concise. 4198.66. What is the ratio of the Exports (in Local Currency Unit) in 1962 in Ireland to that in Israel?
Your response must be concise. 2287.81. What is the ratio of the Exports (in Local Currency Unit) in 1963 in Ireland to that in Israel?
Your answer should be very brief. 2048.97. What is the ratio of the Exports (in Local Currency Unit) in 1960 in Ireland to that in Italy?
Keep it short and to the point. 0.16. What is the ratio of the Exports (in Local Currency Unit) of 1961 in Ireland to that in Italy?
Provide a succinct answer. 0.16. What is the ratio of the Exports (in Local Currency Unit) in 1962 in Ireland to that in Italy?
Your response must be concise. 0.15. What is the ratio of the Exports (in Local Currency Unit) of 1963 in Ireland to that in Italy?
Your answer should be compact. 0.15. What is the ratio of the Exports (in Local Currency Unit) of 1960 in Ireland to that in Kenya?
Your response must be concise. 0.15. What is the ratio of the Exports (in Local Currency Unit) in 1961 in Ireland to that in Kenya?
Give a very brief answer. 0.16. What is the ratio of the Exports (in Local Currency Unit) in 1962 in Ireland to that in Kenya?
Your response must be concise. 0.15. What is the ratio of the Exports (in Local Currency Unit) of 1963 in Ireland to that in Kenya?
Provide a succinct answer. 0.16. What is the ratio of the Exports (in Local Currency Unit) in 1961 in Israel to that in Italy?
Your answer should be very brief. 0. What is the ratio of the Exports (in Local Currency Unit) of 1963 in Israel to that in Kenya?
Keep it short and to the point. 0. What is the ratio of the Exports (in Local Currency Unit) in 1960 in Italy to that in Kenya?
Provide a succinct answer. 0.93. What is the ratio of the Exports (in Local Currency Unit) of 1961 in Italy to that in Kenya?
Provide a succinct answer. 1. What is the ratio of the Exports (in Local Currency Unit) of 1962 in Italy to that in Kenya?
Your answer should be compact. 1.04. What is the ratio of the Exports (in Local Currency Unit) in 1963 in Italy to that in Kenya?
Make the answer very short. 1.07. What is the difference between the highest and the second highest Exports (in Local Currency Unit) of 1960?
Give a very brief answer. 4.23e+1. What is the difference between the highest and the second highest Exports (in Local Currency Unit) of 1961?
Your answer should be compact. 4.42e+1. What is the difference between the highest and the second highest Exports (in Local Currency Unit) in 1962?
Provide a succinct answer. 4.95e+1. What is the difference between the highest and the second highest Exports (in Local Currency Unit) in 1963?
Make the answer very short. 5.50e+1. What is the difference between the highest and the lowest Exports (in Local Currency Unit) of 1960?
Provide a short and direct response. 4.41e+1. What is the difference between the highest and the lowest Exports (in Local Currency Unit) in 1961?
Your answer should be very brief. 4.60e+1. What is the difference between the highest and the lowest Exports (in Local Currency Unit) in 1962?
Make the answer very short. 5.15e+1. What is the difference between the highest and the lowest Exports (in Local Currency Unit) of 1963?
Make the answer very short. 5.72e+1. 